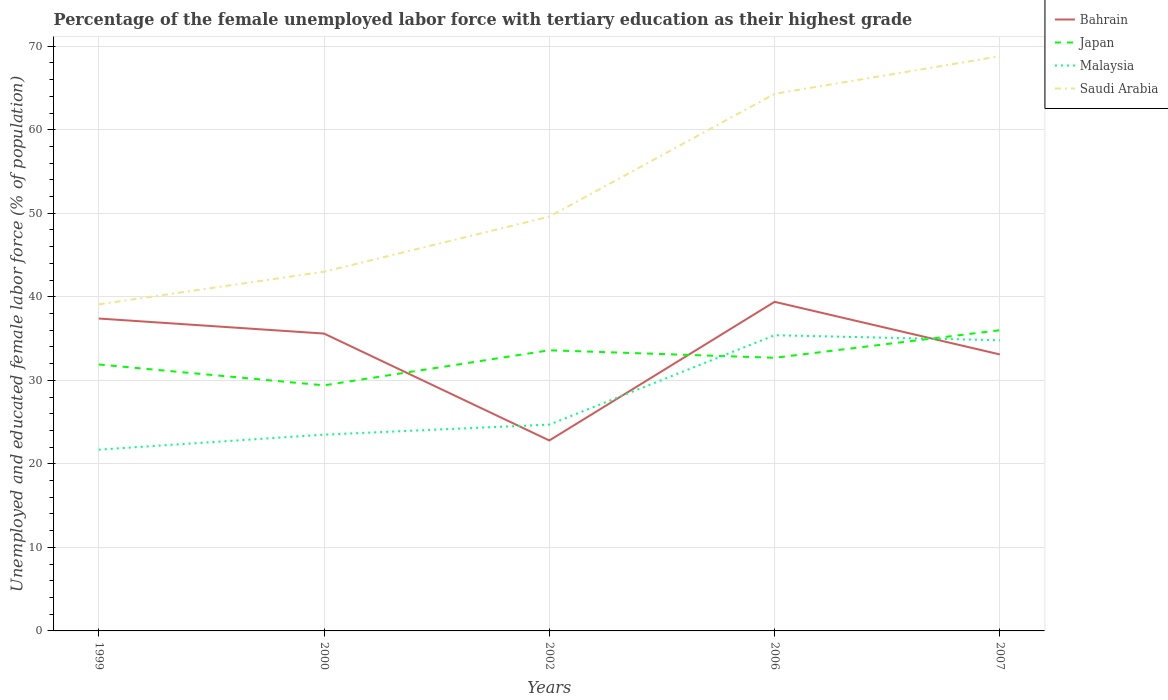Does the line corresponding to Japan intersect with the line corresponding to Malaysia?
Your response must be concise. Yes. Across all years, what is the maximum percentage of the unemployed female labor force with tertiary education in Japan?
Provide a short and direct response. 29.4. What is the total percentage of the unemployed female labor force with tertiary education in Bahrain in the graph?
Make the answer very short. 12.8. What is the difference between the highest and the second highest percentage of the unemployed female labor force with tertiary education in Bahrain?
Your response must be concise. 16.6. What is the difference between the highest and the lowest percentage of the unemployed female labor force with tertiary education in Bahrain?
Keep it short and to the point. 3. Are the values on the major ticks of Y-axis written in scientific E-notation?
Offer a very short reply. No. Does the graph contain any zero values?
Your answer should be compact. No. Does the graph contain grids?
Your answer should be compact. Yes. Where does the legend appear in the graph?
Offer a very short reply. Top right. How many legend labels are there?
Your answer should be very brief. 4. How are the legend labels stacked?
Provide a succinct answer. Vertical. What is the title of the graph?
Keep it short and to the point. Percentage of the female unemployed labor force with tertiary education as their highest grade. What is the label or title of the X-axis?
Give a very brief answer. Years. What is the label or title of the Y-axis?
Ensure brevity in your answer.  Unemployed and educated female labor force (% of population). What is the Unemployed and educated female labor force (% of population) of Bahrain in 1999?
Your answer should be compact. 37.4. What is the Unemployed and educated female labor force (% of population) of Japan in 1999?
Make the answer very short. 31.9. What is the Unemployed and educated female labor force (% of population) in Malaysia in 1999?
Your response must be concise. 21.7. What is the Unemployed and educated female labor force (% of population) in Saudi Arabia in 1999?
Offer a terse response. 39.1. What is the Unemployed and educated female labor force (% of population) of Bahrain in 2000?
Ensure brevity in your answer.  35.6. What is the Unemployed and educated female labor force (% of population) in Japan in 2000?
Provide a succinct answer. 29.4. What is the Unemployed and educated female labor force (% of population) in Malaysia in 2000?
Offer a very short reply. 23.5. What is the Unemployed and educated female labor force (% of population) of Saudi Arabia in 2000?
Provide a succinct answer. 43. What is the Unemployed and educated female labor force (% of population) in Bahrain in 2002?
Offer a very short reply. 22.8. What is the Unemployed and educated female labor force (% of population) of Japan in 2002?
Ensure brevity in your answer.  33.6. What is the Unemployed and educated female labor force (% of population) in Malaysia in 2002?
Make the answer very short. 24.7. What is the Unemployed and educated female labor force (% of population) in Saudi Arabia in 2002?
Offer a very short reply. 49.6. What is the Unemployed and educated female labor force (% of population) in Bahrain in 2006?
Offer a terse response. 39.4. What is the Unemployed and educated female labor force (% of population) of Japan in 2006?
Your response must be concise. 32.7. What is the Unemployed and educated female labor force (% of population) of Malaysia in 2006?
Provide a short and direct response. 35.4. What is the Unemployed and educated female labor force (% of population) in Saudi Arabia in 2006?
Provide a succinct answer. 64.3. What is the Unemployed and educated female labor force (% of population) of Bahrain in 2007?
Provide a succinct answer. 33.1. What is the Unemployed and educated female labor force (% of population) in Malaysia in 2007?
Make the answer very short. 34.8. What is the Unemployed and educated female labor force (% of population) in Saudi Arabia in 2007?
Offer a very short reply. 68.8. Across all years, what is the maximum Unemployed and educated female labor force (% of population) in Bahrain?
Ensure brevity in your answer.  39.4. Across all years, what is the maximum Unemployed and educated female labor force (% of population) in Japan?
Provide a succinct answer. 36. Across all years, what is the maximum Unemployed and educated female labor force (% of population) of Malaysia?
Provide a succinct answer. 35.4. Across all years, what is the maximum Unemployed and educated female labor force (% of population) in Saudi Arabia?
Provide a succinct answer. 68.8. Across all years, what is the minimum Unemployed and educated female labor force (% of population) of Bahrain?
Keep it short and to the point. 22.8. Across all years, what is the minimum Unemployed and educated female labor force (% of population) in Japan?
Your response must be concise. 29.4. Across all years, what is the minimum Unemployed and educated female labor force (% of population) of Malaysia?
Offer a terse response. 21.7. Across all years, what is the minimum Unemployed and educated female labor force (% of population) of Saudi Arabia?
Make the answer very short. 39.1. What is the total Unemployed and educated female labor force (% of population) in Bahrain in the graph?
Provide a short and direct response. 168.3. What is the total Unemployed and educated female labor force (% of population) in Japan in the graph?
Give a very brief answer. 163.6. What is the total Unemployed and educated female labor force (% of population) in Malaysia in the graph?
Ensure brevity in your answer.  140.1. What is the total Unemployed and educated female labor force (% of population) of Saudi Arabia in the graph?
Give a very brief answer. 264.8. What is the difference between the Unemployed and educated female labor force (% of population) of Japan in 1999 and that in 2000?
Provide a short and direct response. 2.5. What is the difference between the Unemployed and educated female labor force (% of population) in Malaysia in 1999 and that in 2000?
Your answer should be compact. -1.8. What is the difference between the Unemployed and educated female labor force (% of population) of Japan in 1999 and that in 2002?
Your answer should be very brief. -1.7. What is the difference between the Unemployed and educated female labor force (% of population) of Malaysia in 1999 and that in 2002?
Make the answer very short. -3. What is the difference between the Unemployed and educated female labor force (% of population) in Malaysia in 1999 and that in 2006?
Provide a short and direct response. -13.7. What is the difference between the Unemployed and educated female labor force (% of population) of Saudi Arabia in 1999 and that in 2006?
Provide a short and direct response. -25.2. What is the difference between the Unemployed and educated female labor force (% of population) in Bahrain in 1999 and that in 2007?
Provide a succinct answer. 4.3. What is the difference between the Unemployed and educated female labor force (% of population) in Japan in 1999 and that in 2007?
Offer a terse response. -4.1. What is the difference between the Unemployed and educated female labor force (% of population) of Saudi Arabia in 1999 and that in 2007?
Ensure brevity in your answer.  -29.7. What is the difference between the Unemployed and educated female labor force (% of population) in Bahrain in 2000 and that in 2002?
Your response must be concise. 12.8. What is the difference between the Unemployed and educated female labor force (% of population) in Japan in 2000 and that in 2002?
Provide a short and direct response. -4.2. What is the difference between the Unemployed and educated female labor force (% of population) in Saudi Arabia in 2000 and that in 2002?
Make the answer very short. -6.6. What is the difference between the Unemployed and educated female labor force (% of population) in Bahrain in 2000 and that in 2006?
Provide a succinct answer. -3.8. What is the difference between the Unemployed and educated female labor force (% of population) of Malaysia in 2000 and that in 2006?
Give a very brief answer. -11.9. What is the difference between the Unemployed and educated female labor force (% of population) of Saudi Arabia in 2000 and that in 2006?
Your answer should be compact. -21.3. What is the difference between the Unemployed and educated female labor force (% of population) of Bahrain in 2000 and that in 2007?
Offer a terse response. 2.5. What is the difference between the Unemployed and educated female labor force (% of population) in Japan in 2000 and that in 2007?
Keep it short and to the point. -6.6. What is the difference between the Unemployed and educated female labor force (% of population) of Saudi Arabia in 2000 and that in 2007?
Make the answer very short. -25.8. What is the difference between the Unemployed and educated female labor force (% of population) in Bahrain in 2002 and that in 2006?
Your response must be concise. -16.6. What is the difference between the Unemployed and educated female labor force (% of population) in Saudi Arabia in 2002 and that in 2006?
Make the answer very short. -14.7. What is the difference between the Unemployed and educated female labor force (% of population) of Japan in 2002 and that in 2007?
Give a very brief answer. -2.4. What is the difference between the Unemployed and educated female labor force (% of population) of Malaysia in 2002 and that in 2007?
Your answer should be compact. -10.1. What is the difference between the Unemployed and educated female labor force (% of population) of Saudi Arabia in 2002 and that in 2007?
Your answer should be compact. -19.2. What is the difference between the Unemployed and educated female labor force (% of population) of Bahrain in 2006 and that in 2007?
Provide a succinct answer. 6.3. What is the difference between the Unemployed and educated female labor force (% of population) in Bahrain in 1999 and the Unemployed and educated female labor force (% of population) in Japan in 2000?
Ensure brevity in your answer.  8. What is the difference between the Unemployed and educated female labor force (% of population) in Bahrain in 1999 and the Unemployed and educated female labor force (% of population) in Malaysia in 2000?
Give a very brief answer. 13.9. What is the difference between the Unemployed and educated female labor force (% of population) of Japan in 1999 and the Unemployed and educated female labor force (% of population) of Saudi Arabia in 2000?
Your answer should be compact. -11.1. What is the difference between the Unemployed and educated female labor force (% of population) in Malaysia in 1999 and the Unemployed and educated female labor force (% of population) in Saudi Arabia in 2000?
Provide a succinct answer. -21.3. What is the difference between the Unemployed and educated female labor force (% of population) of Bahrain in 1999 and the Unemployed and educated female labor force (% of population) of Saudi Arabia in 2002?
Give a very brief answer. -12.2. What is the difference between the Unemployed and educated female labor force (% of population) of Japan in 1999 and the Unemployed and educated female labor force (% of population) of Saudi Arabia in 2002?
Ensure brevity in your answer.  -17.7. What is the difference between the Unemployed and educated female labor force (% of population) of Malaysia in 1999 and the Unemployed and educated female labor force (% of population) of Saudi Arabia in 2002?
Offer a terse response. -27.9. What is the difference between the Unemployed and educated female labor force (% of population) in Bahrain in 1999 and the Unemployed and educated female labor force (% of population) in Japan in 2006?
Give a very brief answer. 4.7. What is the difference between the Unemployed and educated female labor force (% of population) of Bahrain in 1999 and the Unemployed and educated female labor force (% of population) of Saudi Arabia in 2006?
Provide a succinct answer. -26.9. What is the difference between the Unemployed and educated female labor force (% of population) in Japan in 1999 and the Unemployed and educated female labor force (% of population) in Malaysia in 2006?
Keep it short and to the point. -3.5. What is the difference between the Unemployed and educated female labor force (% of population) of Japan in 1999 and the Unemployed and educated female labor force (% of population) of Saudi Arabia in 2006?
Make the answer very short. -32.4. What is the difference between the Unemployed and educated female labor force (% of population) in Malaysia in 1999 and the Unemployed and educated female labor force (% of population) in Saudi Arabia in 2006?
Your response must be concise. -42.6. What is the difference between the Unemployed and educated female labor force (% of population) in Bahrain in 1999 and the Unemployed and educated female labor force (% of population) in Malaysia in 2007?
Keep it short and to the point. 2.6. What is the difference between the Unemployed and educated female labor force (% of population) in Bahrain in 1999 and the Unemployed and educated female labor force (% of population) in Saudi Arabia in 2007?
Your answer should be compact. -31.4. What is the difference between the Unemployed and educated female labor force (% of population) in Japan in 1999 and the Unemployed and educated female labor force (% of population) in Malaysia in 2007?
Your answer should be very brief. -2.9. What is the difference between the Unemployed and educated female labor force (% of population) of Japan in 1999 and the Unemployed and educated female labor force (% of population) of Saudi Arabia in 2007?
Ensure brevity in your answer.  -36.9. What is the difference between the Unemployed and educated female labor force (% of population) of Malaysia in 1999 and the Unemployed and educated female labor force (% of population) of Saudi Arabia in 2007?
Provide a short and direct response. -47.1. What is the difference between the Unemployed and educated female labor force (% of population) in Bahrain in 2000 and the Unemployed and educated female labor force (% of population) in Saudi Arabia in 2002?
Give a very brief answer. -14. What is the difference between the Unemployed and educated female labor force (% of population) in Japan in 2000 and the Unemployed and educated female labor force (% of population) in Saudi Arabia in 2002?
Offer a terse response. -20.2. What is the difference between the Unemployed and educated female labor force (% of population) in Malaysia in 2000 and the Unemployed and educated female labor force (% of population) in Saudi Arabia in 2002?
Provide a succinct answer. -26.1. What is the difference between the Unemployed and educated female labor force (% of population) in Bahrain in 2000 and the Unemployed and educated female labor force (% of population) in Malaysia in 2006?
Ensure brevity in your answer.  0.2. What is the difference between the Unemployed and educated female labor force (% of population) of Bahrain in 2000 and the Unemployed and educated female labor force (% of population) of Saudi Arabia in 2006?
Give a very brief answer. -28.7. What is the difference between the Unemployed and educated female labor force (% of population) of Japan in 2000 and the Unemployed and educated female labor force (% of population) of Saudi Arabia in 2006?
Make the answer very short. -34.9. What is the difference between the Unemployed and educated female labor force (% of population) in Malaysia in 2000 and the Unemployed and educated female labor force (% of population) in Saudi Arabia in 2006?
Offer a terse response. -40.8. What is the difference between the Unemployed and educated female labor force (% of population) of Bahrain in 2000 and the Unemployed and educated female labor force (% of population) of Japan in 2007?
Your answer should be very brief. -0.4. What is the difference between the Unemployed and educated female labor force (% of population) of Bahrain in 2000 and the Unemployed and educated female labor force (% of population) of Saudi Arabia in 2007?
Offer a terse response. -33.2. What is the difference between the Unemployed and educated female labor force (% of population) in Japan in 2000 and the Unemployed and educated female labor force (% of population) in Saudi Arabia in 2007?
Provide a succinct answer. -39.4. What is the difference between the Unemployed and educated female labor force (% of population) in Malaysia in 2000 and the Unemployed and educated female labor force (% of population) in Saudi Arabia in 2007?
Your answer should be compact. -45.3. What is the difference between the Unemployed and educated female labor force (% of population) in Bahrain in 2002 and the Unemployed and educated female labor force (% of population) in Malaysia in 2006?
Give a very brief answer. -12.6. What is the difference between the Unemployed and educated female labor force (% of population) in Bahrain in 2002 and the Unemployed and educated female labor force (% of population) in Saudi Arabia in 2006?
Your answer should be very brief. -41.5. What is the difference between the Unemployed and educated female labor force (% of population) in Japan in 2002 and the Unemployed and educated female labor force (% of population) in Saudi Arabia in 2006?
Your answer should be compact. -30.7. What is the difference between the Unemployed and educated female labor force (% of population) in Malaysia in 2002 and the Unemployed and educated female labor force (% of population) in Saudi Arabia in 2006?
Ensure brevity in your answer.  -39.6. What is the difference between the Unemployed and educated female labor force (% of population) in Bahrain in 2002 and the Unemployed and educated female labor force (% of population) in Malaysia in 2007?
Keep it short and to the point. -12. What is the difference between the Unemployed and educated female labor force (% of population) in Bahrain in 2002 and the Unemployed and educated female labor force (% of population) in Saudi Arabia in 2007?
Offer a very short reply. -46. What is the difference between the Unemployed and educated female labor force (% of population) in Japan in 2002 and the Unemployed and educated female labor force (% of population) in Saudi Arabia in 2007?
Give a very brief answer. -35.2. What is the difference between the Unemployed and educated female labor force (% of population) of Malaysia in 2002 and the Unemployed and educated female labor force (% of population) of Saudi Arabia in 2007?
Ensure brevity in your answer.  -44.1. What is the difference between the Unemployed and educated female labor force (% of population) of Bahrain in 2006 and the Unemployed and educated female labor force (% of population) of Japan in 2007?
Make the answer very short. 3.4. What is the difference between the Unemployed and educated female labor force (% of population) of Bahrain in 2006 and the Unemployed and educated female labor force (% of population) of Malaysia in 2007?
Provide a succinct answer. 4.6. What is the difference between the Unemployed and educated female labor force (% of population) in Bahrain in 2006 and the Unemployed and educated female labor force (% of population) in Saudi Arabia in 2007?
Offer a very short reply. -29.4. What is the difference between the Unemployed and educated female labor force (% of population) of Japan in 2006 and the Unemployed and educated female labor force (% of population) of Saudi Arabia in 2007?
Your response must be concise. -36.1. What is the difference between the Unemployed and educated female labor force (% of population) in Malaysia in 2006 and the Unemployed and educated female labor force (% of population) in Saudi Arabia in 2007?
Your answer should be compact. -33.4. What is the average Unemployed and educated female labor force (% of population) in Bahrain per year?
Give a very brief answer. 33.66. What is the average Unemployed and educated female labor force (% of population) in Japan per year?
Your answer should be very brief. 32.72. What is the average Unemployed and educated female labor force (% of population) of Malaysia per year?
Give a very brief answer. 28.02. What is the average Unemployed and educated female labor force (% of population) in Saudi Arabia per year?
Your answer should be very brief. 52.96. In the year 1999, what is the difference between the Unemployed and educated female labor force (% of population) in Bahrain and Unemployed and educated female labor force (% of population) in Malaysia?
Ensure brevity in your answer.  15.7. In the year 1999, what is the difference between the Unemployed and educated female labor force (% of population) of Japan and Unemployed and educated female labor force (% of population) of Saudi Arabia?
Provide a short and direct response. -7.2. In the year 1999, what is the difference between the Unemployed and educated female labor force (% of population) of Malaysia and Unemployed and educated female labor force (% of population) of Saudi Arabia?
Keep it short and to the point. -17.4. In the year 2000, what is the difference between the Unemployed and educated female labor force (% of population) in Bahrain and Unemployed and educated female labor force (% of population) in Japan?
Give a very brief answer. 6.2. In the year 2000, what is the difference between the Unemployed and educated female labor force (% of population) in Bahrain and Unemployed and educated female labor force (% of population) in Malaysia?
Offer a terse response. 12.1. In the year 2000, what is the difference between the Unemployed and educated female labor force (% of population) of Bahrain and Unemployed and educated female labor force (% of population) of Saudi Arabia?
Make the answer very short. -7.4. In the year 2000, what is the difference between the Unemployed and educated female labor force (% of population) in Japan and Unemployed and educated female labor force (% of population) in Saudi Arabia?
Your answer should be compact. -13.6. In the year 2000, what is the difference between the Unemployed and educated female labor force (% of population) in Malaysia and Unemployed and educated female labor force (% of population) in Saudi Arabia?
Provide a short and direct response. -19.5. In the year 2002, what is the difference between the Unemployed and educated female labor force (% of population) in Bahrain and Unemployed and educated female labor force (% of population) in Saudi Arabia?
Make the answer very short. -26.8. In the year 2002, what is the difference between the Unemployed and educated female labor force (% of population) of Japan and Unemployed and educated female labor force (% of population) of Malaysia?
Make the answer very short. 8.9. In the year 2002, what is the difference between the Unemployed and educated female labor force (% of population) of Malaysia and Unemployed and educated female labor force (% of population) of Saudi Arabia?
Keep it short and to the point. -24.9. In the year 2006, what is the difference between the Unemployed and educated female labor force (% of population) in Bahrain and Unemployed and educated female labor force (% of population) in Japan?
Provide a short and direct response. 6.7. In the year 2006, what is the difference between the Unemployed and educated female labor force (% of population) of Bahrain and Unemployed and educated female labor force (% of population) of Saudi Arabia?
Your answer should be compact. -24.9. In the year 2006, what is the difference between the Unemployed and educated female labor force (% of population) in Japan and Unemployed and educated female labor force (% of population) in Saudi Arabia?
Your answer should be very brief. -31.6. In the year 2006, what is the difference between the Unemployed and educated female labor force (% of population) in Malaysia and Unemployed and educated female labor force (% of population) in Saudi Arabia?
Offer a very short reply. -28.9. In the year 2007, what is the difference between the Unemployed and educated female labor force (% of population) in Bahrain and Unemployed and educated female labor force (% of population) in Malaysia?
Ensure brevity in your answer.  -1.7. In the year 2007, what is the difference between the Unemployed and educated female labor force (% of population) in Bahrain and Unemployed and educated female labor force (% of population) in Saudi Arabia?
Provide a short and direct response. -35.7. In the year 2007, what is the difference between the Unemployed and educated female labor force (% of population) in Japan and Unemployed and educated female labor force (% of population) in Malaysia?
Make the answer very short. 1.2. In the year 2007, what is the difference between the Unemployed and educated female labor force (% of population) in Japan and Unemployed and educated female labor force (% of population) in Saudi Arabia?
Your answer should be very brief. -32.8. In the year 2007, what is the difference between the Unemployed and educated female labor force (% of population) of Malaysia and Unemployed and educated female labor force (% of population) of Saudi Arabia?
Offer a very short reply. -34. What is the ratio of the Unemployed and educated female labor force (% of population) of Bahrain in 1999 to that in 2000?
Offer a terse response. 1.05. What is the ratio of the Unemployed and educated female labor force (% of population) in Japan in 1999 to that in 2000?
Offer a terse response. 1.08. What is the ratio of the Unemployed and educated female labor force (% of population) in Malaysia in 1999 to that in 2000?
Your answer should be very brief. 0.92. What is the ratio of the Unemployed and educated female labor force (% of population) in Saudi Arabia in 1999 to that in 2000?
Offer a terse response. 0.91. What is the ratio of the Unemployed and educated female labor force (% of population) in Bahrain in 1999 to that in 2002?
Provide a short and direct response. 1.64. What is the ratio of the Unemployed and educated female labor force (% of population) of Japan in 1999 to that in 2002?
Your answer should be compact. 0.95. What is the ratio of the Unemployed and educated female labor force (% of population) in Malaysia in 1999 to that in 2002?
Offer a terse response. 0.88. What is the ratio of the Unemployed and educated female labor force (% of population) of Saudi Arabia in 1999 to that in 2002?
Your answer should be very brief. 0.79. What is the ratio of the Unemployed and educated female labor force (% of population) in Bahrain in 1999 to that in 2006?
Provide a short and direct response. 0.95. What is the ratio of the Unemployed and educated female labor force (% of population) of Japan in 1999 to that in 2006?
Make the answer very short. 0.98. What is the ratio of the Unemployed and educated female labor force (% of population) in Malaysia in 1999 to that in 2006?
Provide a succinct answer. 0.61. What is the ratio of the Unemployed and educated female labor force (% of population) of Saudi Arabia in 1999 to that in 2006?
Make the answer very short. 0.61. What is the ratio of the Unemployed and educated female labor force (% of population) of Bahrain in 1999 to that in 2007?
Keep it short and to the point. 1.13. What is the ratio of the Unemployed and educated female labor force (% of population) in Japan in 1999 to that in 2007?
Provide a succinct answer. 0.89. What is the ratio of the Unemployed and educated female labor force (% of population) of Malaysia in 1999 to that in 2007?
Offer a very short reply. 0.62. What is the ratio of the Unemployed and educated female labor force (% of population) of Saudi Arabia in 1999 to that in 2007?
Offer a terse response. 0.57. What is the ratio of the Unemployed and educated female labor force (% of population) of Bahrain in 2000 to that in 2002?
Offer a terse response. 1.56. What is the ratio of the Unemployed and educated female labor force (% of population) of Japan in 2000 to that in 2002?
Ensure brevity in your answer.  0.88. What is the ratio of the Unemployed and educated female labor force (% of population) of Malaysia in 2000 to that in 2002?
Make the answer very short. 0.95. What is the ratio of the Unemployed and educated female labor force (% of population) of Saudi Arabia in 2000 to that in 2002?
Keep it short and to the point. 0.87. What is the ratio of the Unemployed and educated female labor force (% of population) in Bahrain in 2000 to that in 2006?
Provide a short and direct response. 0.9. What is the ratio of the Unemployed and educated female labor force (% of population) in Japan in 2000 to that in 2006?
Offer a terse response. 0.9. What is the ratio of the Unemployed and educated female labor force (% of population) of Malaysia in 2000 to that in 2006?
Give a very brief answer. 0.66. What is the ratio of the Unemployed and educated female labor force (% of population) of Saudi Arabia in 2000 to that in 2006?
Provide a short and direct response. 0.67. What is the ratio of the Unemployed and educated female labor force (% of population) of Bahrain in 2000 to that in 2007?
Make the answer very short. 1.08. What is the ratio of the Unemployed and educated female labor force (% of population) of Japan in 2000 to that in 2007?
Make the answer very short. 0.82. What is the ratio of the Unemployed and educated female labor force (% of population) of Malaysia in 2000 to that in 2007?
Give a very brief answer. 0.68. What is the ratio of the Unemployed and educated female labor force (% of population) in Saudi Arabia in 2000 to that in 2007?
Make the answer very short. 0.62. What is the ratio of the Unemployed and educated female labor force (% of population) of Bahrain in 2002 to that in 2006?
Give a very brief answer. 0.58. What is the ratio of the Unemployed and educated female labor force (% of population) in Japan in 2002 to that in 2006?
Provide a succinct answer. 1.03. What is the ratio of the Unemployed and educated female labor force (% of population) of Malaysia in 2002 to that in 2006?
Your answer should be compact. 0.7. What is the ratio of the Unemployed and educated female labor force (% of population) of Saudi Arabia in 2002 to that in 2006?
Keep it short and to the point. 0.77. What is the ratio of the Unemployed and educated female labor force (% of population) of Bahrain in 2002 to that in 2007?
Your answer should be very brief. 0.69. What is the ratio of the Unemployed and educated female labor force (% of population) in Japan in 2002 to that in 2007?
Provide a succinct answer. 0.93. What is the ratio of the Unemployed and educated female labor force (% of population) in Malaysia in 2002 to that in 2007?
Your response must be concise. 0.71. What is the ratio of the Unemployed and educated female labor force (% of population) in Saudi Arabia in 2002 to that in 2007?
Your answer should be very brief. 0.72. What is the ratio of the Unemployed and educated female labor force (% of population) of Bahrain in 2006 to that in 2007?
Your answer should be compact. 1.19. What is the ratio of the Unemployed and educated female labor force (% of population) in Japan in 2006 to that in 2007?
Your answer should be very brief. 0.91. What is the ratio of the Unemployed and educated female labor force (% of population) of Malaysia in 2006 to that in 2007?
Your answer should be very brief. 1.02. What is the ratio of the Unemployed and educated female labor force (% of population) in Saudi Arabia in 2006 to that in 2007?
Make the answer very short. 0.93. What is the difference between the highest and the second highest Unemployed and educated female labor force (% of population) in Japan?
Provide a succinct answer. 2.4. What is the difference between the highest and the second highest Unemployed and educated female labor force (% of population) of Saudi Arabia?
Your response must be concise. 4.5. What is the difference between the highest and the lowest Unemployed and educated female labor force (% of population) in Bahrain?
Keep it short and to the point. 16.6. What is the difference between the highest and the lowest Unemployed and educated female labor force (% of population) in Saudi Arabia?
Provide a succinct answer. 29.7. 